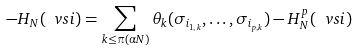Convert formula to latex. <formula><loc_0><loc_0><loc_500><loc_500>- H _ { N } ( \ v s i ) = \sum _ { k \leq \pi ( \alpha N ) } \theta _ { k } ( \sigma _ { i _ { 1 , k } } , \dots , \sigma _ { i _ { p , k } } ) - H _ { N } ^ { p } ( \ v s i )</formula> 